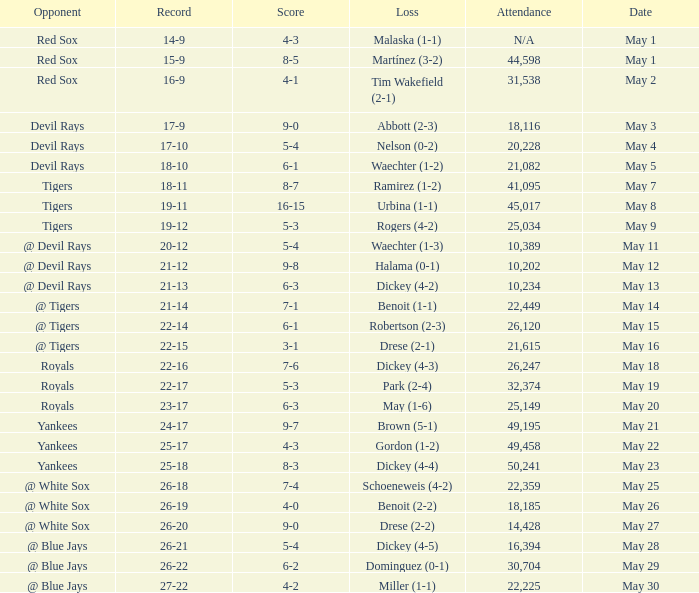What was the score of the game that had a loss of Drese (2-2)? 9-0. 